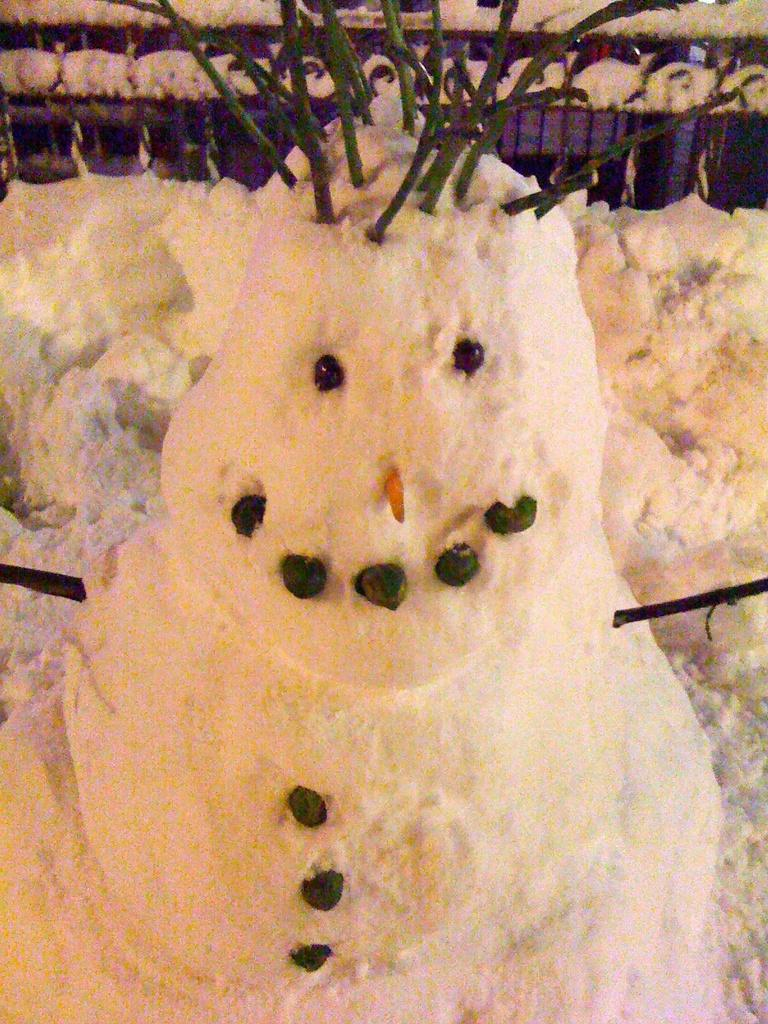What is the main subject in the foreground of the image? There is a snowman in the foreground of the image. What can be seen in the background of the image? There is snow on the ground in the background of the image. What type of furniture can be seen in the image? There is no furniture present in the image; it features a snowman in the foreground and snow on the ground in the background. Can you hear the snowman crying in the image? Snowmen do not have the ability to cry, and there is no sound associated with the image. 